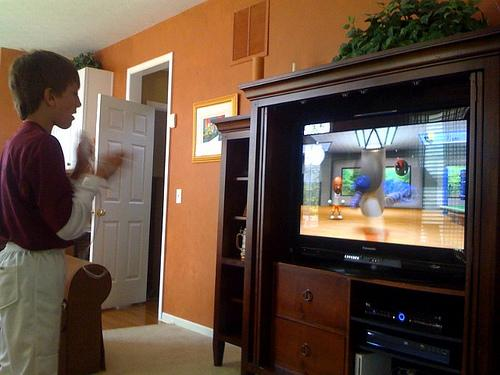What is the person engaged in?

Choices:
A) gaming
B) debate
C) discussion
D) sports gaming 